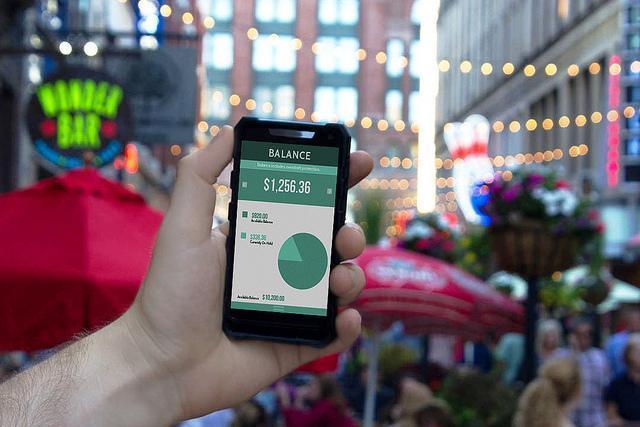How many limbs are shown?
Give a very brief answer. 1. How many cell phones are in the photo?
Give a very brief answer. 1. How many umbrellas can you see?
Give a very brief answer. 2. How many people can be seen?
Give a very brief answer. 5. How many zebra are in this field?
Give a very brief answer. 0. 